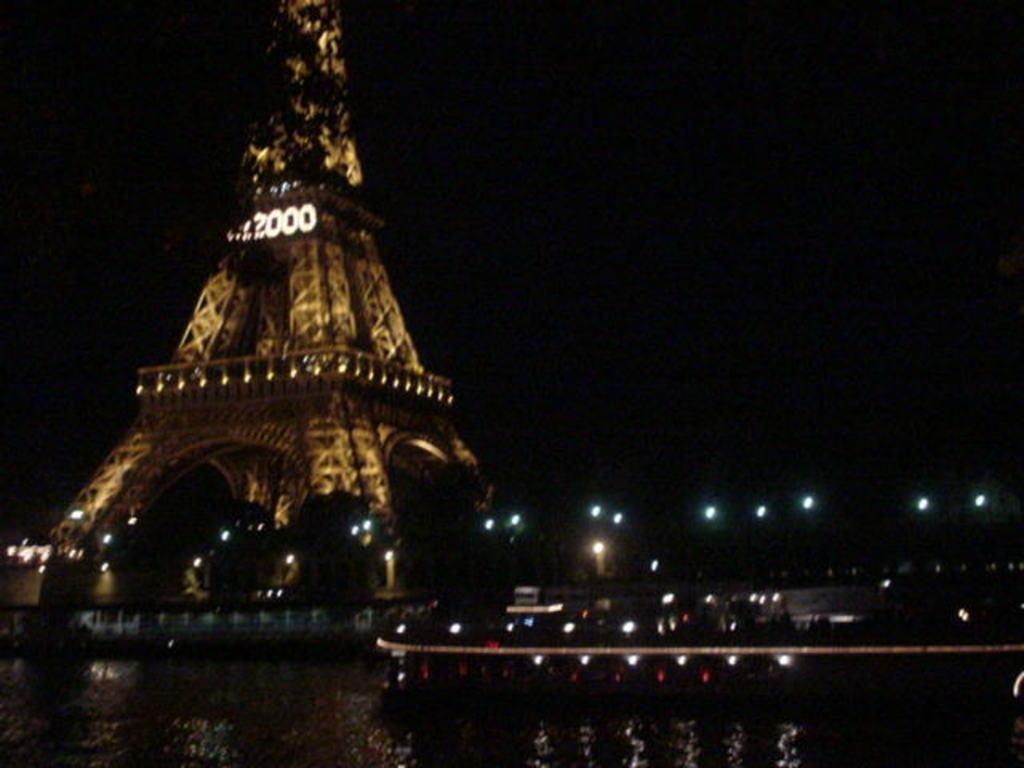What is the overall lighting condition in the image? The image is dark. What structure can be seen on the left side of the image? There is a tower on the left side of the image. What can be observed on the right side of the image? There are many lights on the right side of the image. What color is the background of the image? The background of the image is black. What type of hook can be seen in the image? There is no hook present in the image. What event is taking place in the image? The image does not depict any specific event or activity. 